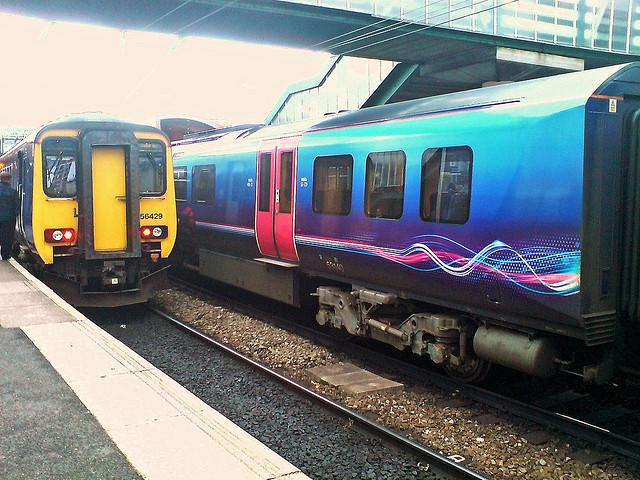What structure is present above the parked trains on the rail tracks? Please explain your reasoning. passenger walkway. The structure is there for passengers to walk on. 